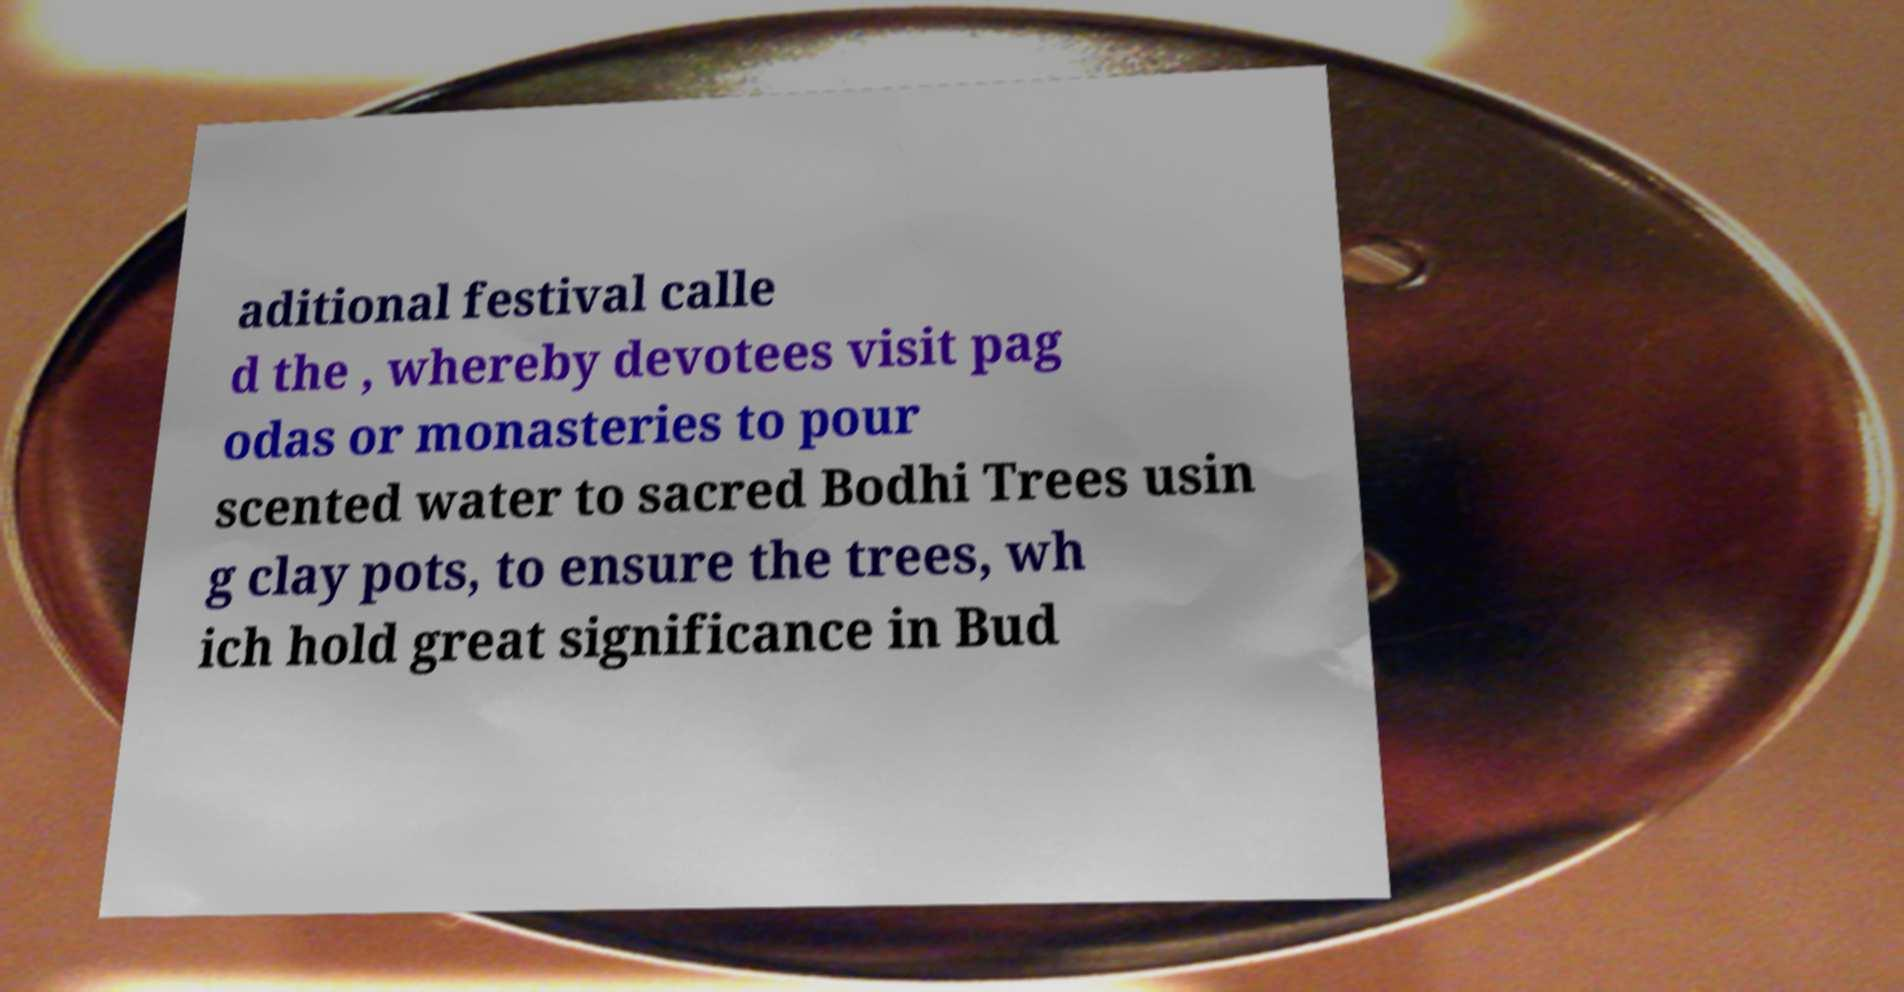What messages or text are displayed in this image? I need them in a readable, typed format. aditional festival calle d the , whereby devotees visit pag odas or monasteries to pour scented water to sacred Bodhi Trees usin g clay pots, to ensure the trees, wh ich hold great significance in Bud 